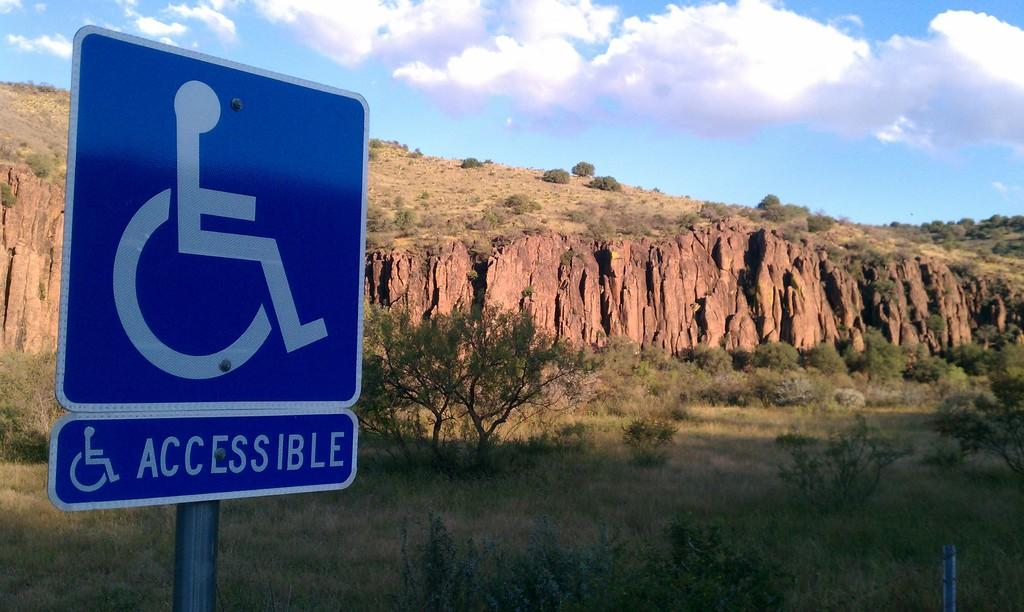<image>
Relay a brief, clear account of the picture shown. A blue and white sign for a handicapped person with the word accessible written on it. 